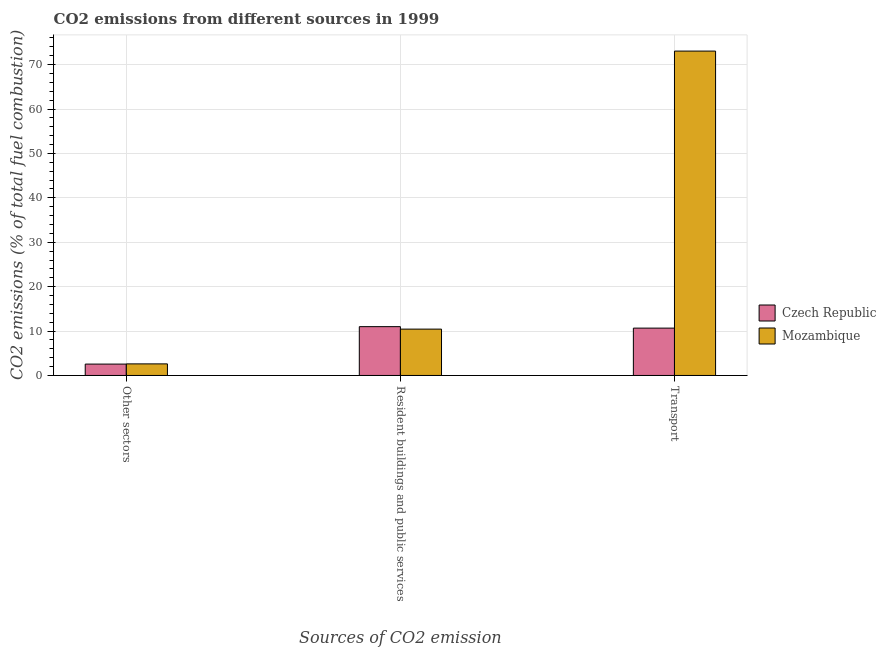Are the number of bars on each tick of the X-axis equal?
Your answer should be very brief. Yes. How many bars are there on the 1st tick from the left?
Provide a short and direct response. 2. What is the label of the 3rd group of bars from the left?
Your response must be concise. Transport. What is the percentage of co2 emissions from resident buildings and public services in Mozambique?
Ensure brevity in your answer.  10.43. Across all countries, what is the maximum percentage of co2 emissions from resident buildings and public services?
Your answer should be compact. 10.99. Across all countries, what is the minimum percentage of co2 emissions from transport?
Offer a very short reply. 10.66. In which country was the percentage of co2 emissions from resident buildings and public services maximum?
Ensure brevity in your answer.  Czech Republic. In which country was the percentage of co2 emissions from other sectors minimum?
Your answer should be compact. Czech Republic. What is the total percentage of co2 emissions from transport in the graph?
Make the answer very short. 83.7. What is the difference between the percentage of co2 emissions from transport in Czech Republic and that in Mozambique?
Your answer should be very brief. -62.38. What is the difference between the percentage of co2 emissions from transport in Czech Republic and the percentage of co2 emissions from resident buildings and public services in Mozambique?
Your answer should be compact. 0.23. What is the average percentage of co2 emissions from transport per country?
Your answer should be very brief. 41.85. What is the difference between the percentage of co2 emissions from transport and percentage of co2 emissions from resident buildings and public services in Czech Republic?
Offer a very short reply. -0.33. In how many countries, is the percentage of co2 emissions from other sectors greater than 18 %?
Provide a short and direct response. 0. What is the ratio of the percentage of co2 emissions from resident buildings and public services in Czech Republic to that in Mozambique?
Keep it short and to the point. 1.05. Is the percentage of co2 emissions from transport in Czech Republic less than that in Mozambique?
Your response must be concise. Yes. What is the difference between the highest and the second highest percentage of co2 emissions from resident buildings and public services?
Offer a very short reply. 0.56. What is the difference between the highest and the lowest percentage of co2 emissions from transport?
Give a very brief answer. 62.38. In how many countries, is the percentage of co2 emissions from other sectors greater than the average percentage of co2 emissions from other sectors taken over all countries?
Provide a short and direct response. 1. What does the 2nd bar from the left in Other sectors represents?
Offer a very short reply. Mozambique. What does the 1st bar from the right in Resident buildings and public services represents?
Offer a terse response. Mozambique. How many countries are there in the graph?
Provide a succinct answer. 2. What is the difference between two consecutive major ticks on the Y-axis?
Give a very brief answer. 10. Does the graph contain any zero values?
Your response must be concise. No. Does the graph contain grids?
Your response must be concise. Yes. Where does the legend appear in the graph?
Your answer should be compact. Center right. How are the legend labels stacked?
Provide a short and direct response. Vertical. What is the title of the graph?
Offer a terse response. CO2 emissions from different sources in 1999. What is the label or title of the X-axis?
Your response must be concise. Sources of CO2 emission. What is the label or title of the Y-axis?
Provide a succinct answer. CO2 emissions (% of total fuel combustion). What is the CO2 emissions (% of total fuel combustion) in Czech Republic in Other sectors?
Ensure brevity in your answer.  2.56. What is the CO2 emissions (% of total fuel combustion) in Mozambique in Other sectors?
Your response must be concise. 2.61. What is the CO2 emissions (% of total fuel combustion) in Czech Republic in Resident buildings and public services?
Provide a succinct answer. 10.99. What is the CO2 emissions (% of total fuel combustion) of Mozambique in Resident buildings and public services?
Provide a short and direct response. 10.43. What is the CO2 emissions (% of total fuel combustion) in Czech Republic in Transport?
Provide a short and direct response. 10.66. What is the CO2 emissions (% of total fuel combustion) of Mozambique in Transport?
Provide a short and direct response. 73.04. Across all Sources of CO2 emission, what is the maximum CO2 emissions (% of total fuel combustion) in Czech Republic?
Your response must be concise. 10.99. Across all Sources of CO2 emission, what is the maximum CO2 emissions (% of total fuel combustion) in Mozambique?
Your answer should be compact. 73.04. Across all Sources of CO2 emission, what is the minimum CO2 emissions (% of total fuel combustion) in Czech Republic?
Provide a succinct answer. 2.56. Across all Sources of CO2 emission, what is the minimum CO2 emissions (% of total fuel combustion) of Mozambique?
Your response must be concise. 2.61. What is the total CO2 emissions (% of total fuel combustion) in Czech Republic in the graph?
Your answer should be compact. 24.21. What is the total CO2 emissions (% of total fuel combustion) in Mozambique in the graph?
Ensure brevity in your answer.  86.09. What is the difference between the CO2 emissions (% of total fuel combustion) of Czech Republic in Other sectors and that in Resident buildings and public services?
Give a very brief answer. -8.43. What is the difference between the CO2 emissions (% of total fuel combustion) in Mozambique in Other sectors and that in Resident buildings and public services?
Keep it short and to the point. -7.83. What is the difference between the CO2 emissions (% of total fuel combustion) in Czech Republic in Other sectors and that in Transport?
Offer a very short reply. -8.1. What is the difference between the CO2 emissions (% of total fuel combustion) in Mozambique in Other sectors and that in Transport?
Provide a short and direct response. -70.43. What is the difference between the CO2 emissions (% of total fuel combustion) of Czech Republic in Resident buildings and public services and that in Transport?
Make the answer very short. 0.33. What is the difference between the CO2 emissions (% of total fuel combustion) in Mozambique in Resident buildings and public services and that in Transport?
Keep it short and to the point. -62.61. What is the difference between the CO2 emissions (% of total fuel combustion) of Czech Republic in Other sectors and the CO2 emissions (% of total fuel combustion) of Mozambique in Resident buildings and public services?
Keep it short and to the point. -7.87. What is the difference between the CO2 emissions (% of total fuel combustion) in Czech Republic in Other sectors and the CO2 emissions (% of total fuel combustion) in Mozambique in Transport?
Give a very brief answer. -70.48. What is the difference between the CO2 emissions (% of total fuel combustion) of Czech Republic in Resident buildings and public services and the CO2 emissions (% of total fuel combustion) of Mozambique in Transport?
Offer a very short reply. -62.05. What is the average CO2 emissions (% of total fuel combustion) of Czech Republic per Sources of CO2 emission?
Provide a short and direct response. 8.07. What is the average CO2 emissions (% of total fuel combustion) in Mozambique per Sources of CO2 emission?
Your response must be concise. 28.7. What is the difference between the CO2 emissions (% of total fuel combustion) of Czech Republic and CO2 emissions (% of total fuel combustion) of Mozambique in Other sectors?
Give a very brief answer. -0.05. What is the difference between the CO2 emissions (% of total fuel combustion) of Czech Republic and CO2 emissions (% of total fuel combustion) of Mozambique in Resident buildings and public services?
Offer a terse response. 0.56. What is the difference between the CO2 emissions (% of total fuel combustion) in Czech Republic and CO2 emissions (% of total fuel combustion) in Mozambique in Transport?
Give a very brief answer. -62.38. What is the ratio of the CO2 emissions (% of total fuel combustion) of Czech Republic in Other sectors to that in Resident buildings and public services?
Your answer should be very brief. 0.23. What is the ratio of the CO2 emissions (% of total fuel combustion) in Mozambique in Other sectors to that in Resident buildings and public services?
Keep it short and to the point. 0.25. What is the ratio of the CO2 emissions (% of total fuel combustion) of Czech Republic in Other sectors to that in Transport?
Provide a short and direct response. 0.24. What is the ratio of the CO2 emissions (% of total fuel combustion) of Mozambique in Other sectors to that in Transport?
Offer a very short reply. 0.04. What is the ratio of the CO2 emissions (% of total fuel combustion) of Czech Republic in Resident buildings and public services to that in Transport?
Provide a short and direct response. 1.03. What is the ratio of the CO2 emissions (% of total fuel combustion) of Mozambique in Resident buildings and public services to that in Transport?
Keep it short and to the point. 0.14. What is the difference between the highest and the second highest CO2 emissions (% of total fuel combustion) of Czech Republic?
Offer a very short reply. 0.33. What is the difference between the highest and the second highest CO2 emissions (% of total fuel combustion) of Mozambique?
Give a very brief answer. 62.61. What is the difference between the highest and the lowest CO2 emissions (% of total fuel combustion) of Czech Republic?
Keep it short and to the point. 8.43. What is the difference between the highest and the lowest CO2 emissions (% of total fuel combustion) of Mozambique?
Offer a very short reply. 70.43. 